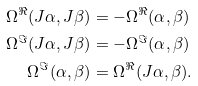<formula> <loc_0><loc_0><loc_500><loc_500>\Omega ^ { \Re } ( J \alpha , J \beta ) & = - \Omega ^ { \Re } ( \alpha , \beta ) \\ \Omega ^ { \Im } ( J \alpha , J \beta ) & = - \Omega ^ { \Im } ( \alpha , \beta ) \\ \Omega ^ { \Im } ( \alpha , \beta ) & = \Omega ^ { \Re } ( J \alpha , \beta ) .</formula> 